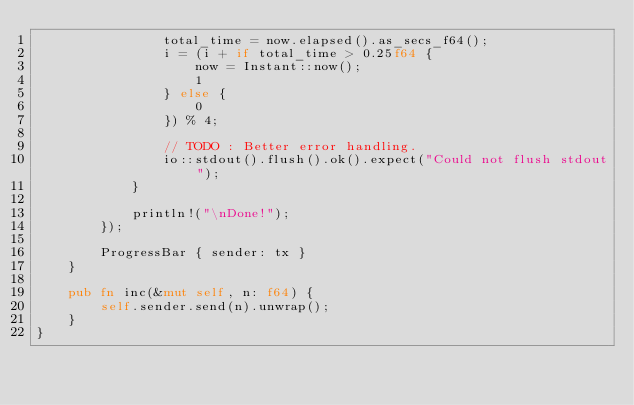<code> <loc_0><loc_0><loc_500><loc_500><_Rust_>                total_time = now.elapsed().as_secs_f64();
                i = (i + if total_time > 0.25f64 {
                    now = Instant::now();
                    1
                } else {
                    0
                }) % 4;

                // TODO : Better error handling.
                io::stdout().flush().ok().expect("Could not flush stdout");
            }

            println!("\nDone!");
        });

        ProgressBar { sender: tx }
    }

    pub fn inc(&mut self, n: f64) {
        self.sender.send(n).unwrap();
    }
}
</code> 